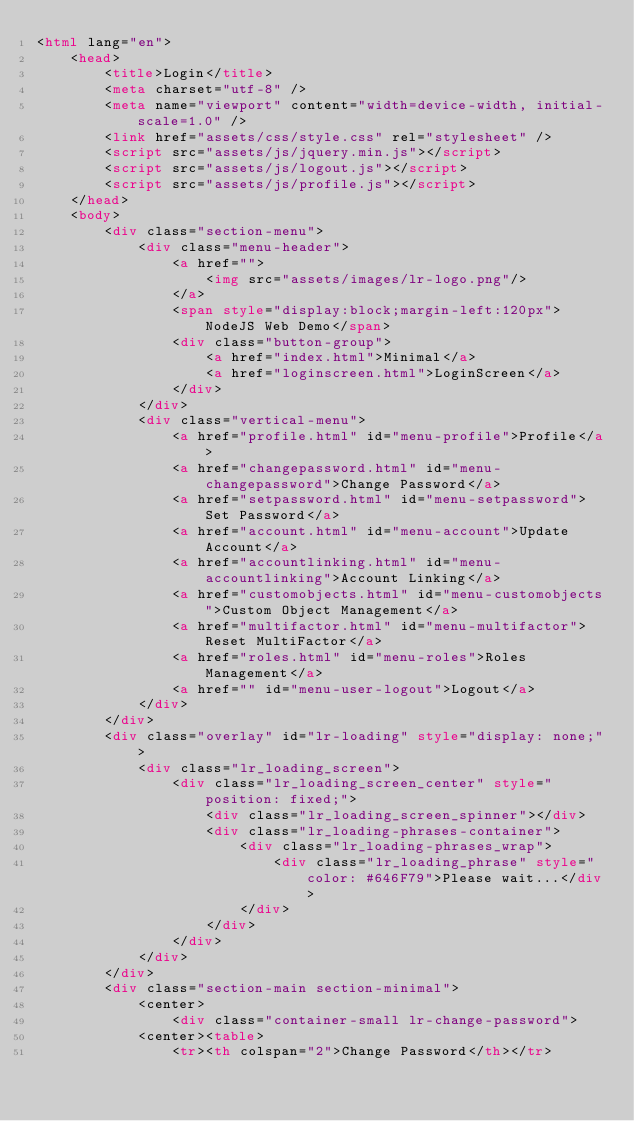Convert code to text. <code><loc_0><loc_0><loc_500><loc_500><_HTML_><html lang="en">
    <head>
        <title>Login</title>
        <meta charset="utf-8" />
        <meta name="viewport" content="width=device-width, initial-scale=1.0" />
        <link href="assets/css/style.css" rel="stylesheet" />
        <script src="assets/js/jquery.min.js"></script> 
        <script src="assets/js/logout.js"></script>  
        <script src="assets/js/profile.js"></script>  
    </head>
    <body>
        <div class="section-menu">
            <div class="menu-header">
                <a href="">
                    <img src="assets/images/lr-logo.png"/>
                </a>
                <span style="display:block;margin-left:120px">NodeJS Web Demo</span>
                <div class="button-group">
                    <a href="index.html">Minimal</a>
                    <a href="loginscreen.html">LoginScreen</a>
                </div>
            </div>
            <div class="vertical-menu">
                <a href="profile.html" id="menu-profile">Profile</a>
                <a href="changepassword.html" id="menu-changepassword">Change Password</a>
                <a href="setpassword.html" id="menu-setpassword">Set Password</a>
                <a href="account.html" id="menu-account">Update Account</a>
                <a href="accountlinking.html" id="menu-accountlinking">Account Linking</a>
                <a href="customobjects.html" id="menu-customobjects">Custom Object Management</a>
                <a href="multifactor.html" id="menu-multifactor">Reset MultiFactor</a>
                <a href="roles.html" id="menu-roles">Roles Management</a>
                <a href="" id="menu-user-logout">Logout</a>
            </div>
        </div>
        <div class="overlay" id="lr-loading" style="display: none;">
            <div class="lr_loading_screen">
                <div class="lr_loading_screen_center" style="position: fixed;">
                    <div class="lr_loading_screen_spinner"></div> 
                    <div class="lr_loading-phrases-container">
                        <div class="lr_loading-phrases_wrap">
                            <div class="lr_loading_phrase" style="color: #646F79">Please wait...</div>                      
                        </div>              
                    </div>                                   
                </div>     
            </div>
        </div>
        <div class="section-main section-minimal">
            <center>
                <div class="container-small lr-change-password">
			<center><table>
                <tr><th colspan="2">Change Password</th></tr></code> 